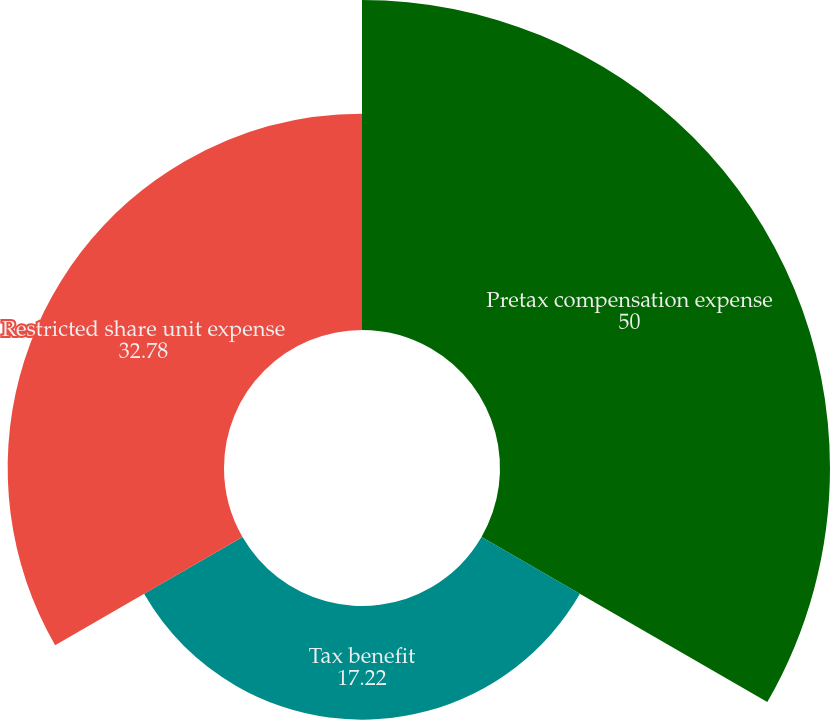<chart> <loc_0><loc_0><loc_500><loc_500><pie_chart><fcel>Pretax compensation expense<fcel>Tax benefit<fcel>Restricted share unit expense<nl><fcel>50.0%<fcel>17.22%<fcel>32.78%<nl></chart> 